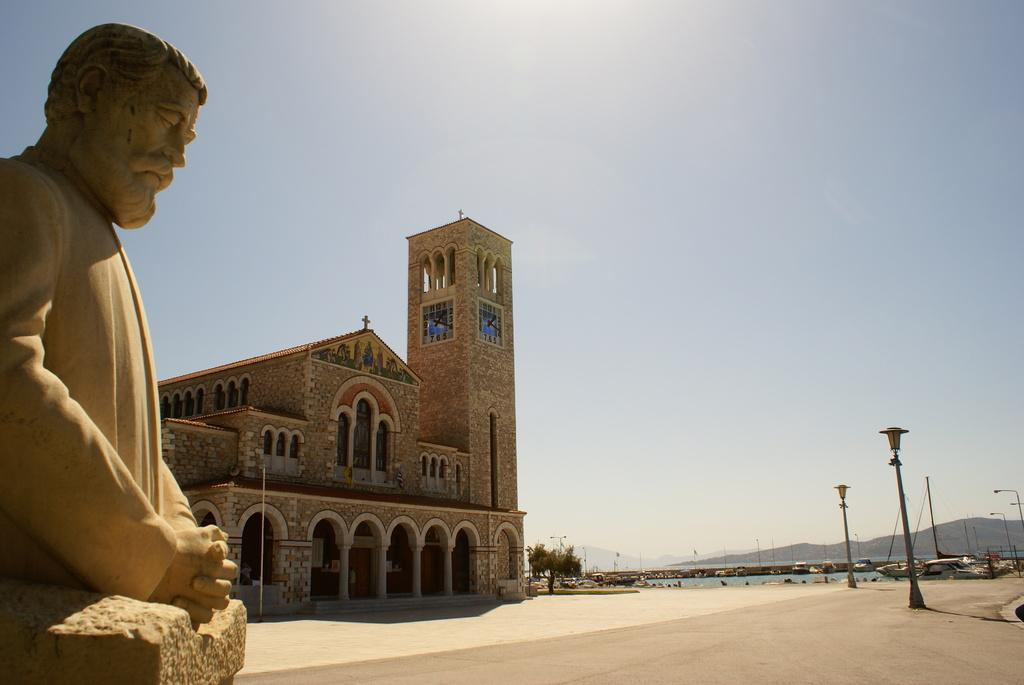What is the main subject in the image? There is a statue of a person in the image. What can be seen in the background of the image? There is a building, many poles, a tree, water, mountains, and the sky visible in the background of the image. Can you see a person kicking a bread in the image? There is no person kicking a bread in the image; it features a statue of a person and various background elements. 